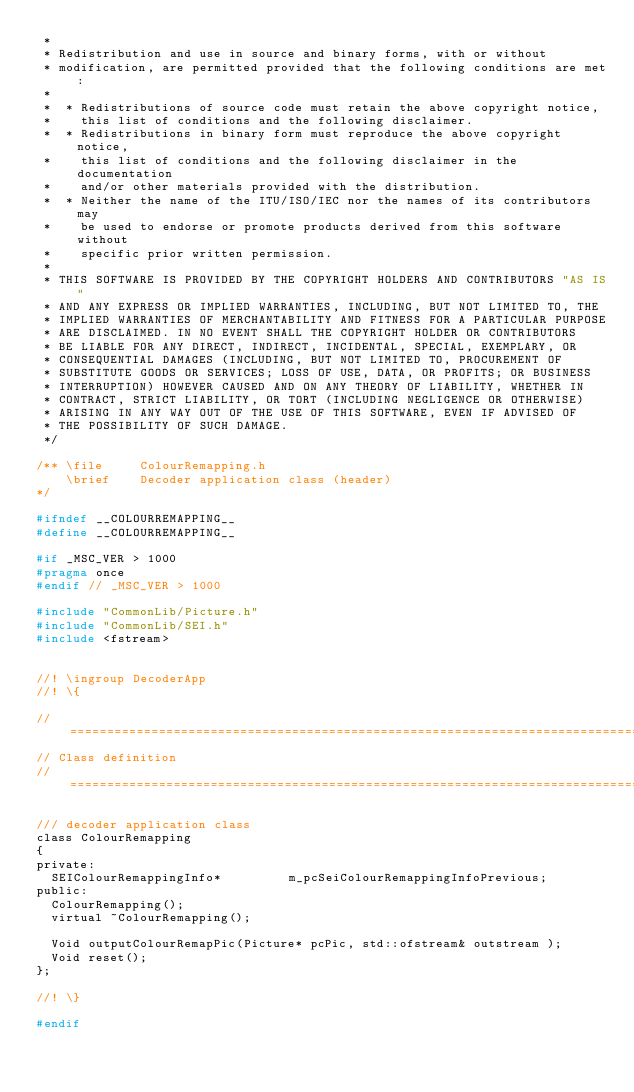<code> <loc_0><loc_0><loc_500><loc_500><_C_> *
 * Redistribution and use in source and binary forms, with or without
 * modification, are permitted provided that the following conditions are met:
 *
 *  * Redistributions of source code must retain the above copyright notice,
 *    this list of conditions and the following disclaimer.
 *  * Redistributions in binary form must reproduce the above copyright notice,
 *    this list of conditions and the following disclaimer in the documentation
 *    and/or other materials provided with the distribution.
 *  * Neither the name of the ITU/ISO/IEC nor the names of its contributors may
 *    be used to endorse or promote products derived from this software without
 *    specific prior written permission.
 *
 * THIS SOFTWARE IS PROVIDED BY THE COPYRIGHT HOLDERS AND CONTRIBUTORS "AS IS"
 * AND ANY EXPRESS OR IMPLIED WARRANTIES, INCLUDING, BUT NOT LIMITED TO, THE
 * IMPLIED WARRANTIES OF MERCHANTABILITY AND FITNESS FOR A PARTICULAR PURPOSE
 * ARE DISCLAIMED. IN NO EVENT SHALL THE COPYRIGHT HOLDER OR CONTRIBUTORS
 * BE LIABLE FOR ANY DIRECT, INDIRECT, INCIDENTAL, SPECIAL, EXEMPLARY, OR
 * CONSEQUENTIAL DAMAGES (INCLUDING, BUT NOT LIMITED TO, PROCUREMENT OF
 * SUBSTITUTE GOODS OR SERVICES; LOSS OF USE, DATA, OR PROFITS; OR BUSINESS
 * INTERRUPTION) HOWEVER CAUSED AND ON ANY THEORY OF LIABILITY, WHETHER IN
 * CONTRACT, STRICT LIABILITY, OR TORT (INCLUDING NEGLIGENCE OR OTHERWISE)
 * ARISING IN ANY WAY OUT OF THE USE OF THIS SOFTWARE, EVEN IF ADVISED OF
 * THE POSSIBILITY OF SUCH DAMAGE.
 */

/** \file     ColourRemapping.h
    \brief    Decoder application class (header)
*/

#ifndef __COLOURREMAPPING__
#define __COLOURREMAPPING__

#if _MSC_VER > 1000
#pragma once
#endif // _MSC_VER > 1000

#include "CommonLib/Picture.h"
#include "CommonLib/SEI.h"
#include <fstream>


//! \ingroup DecoderApp
//! \{

// ====================================================================================================================
// Class definition
// ====================================================================================================================

/// decoder application class
class ColourRemapping
{
private:
  SEIColourRemappingInfo*         m_pcSeiColourRemappingInfoPrevious;
public:
  ColourRemapping();
  virtual ~ColourRemapping();

  Void outputColourRemapPic(Picture* pcPic, std::ofstream& outstream );
  Void reset();
};

//! \}

#endif

</code> 